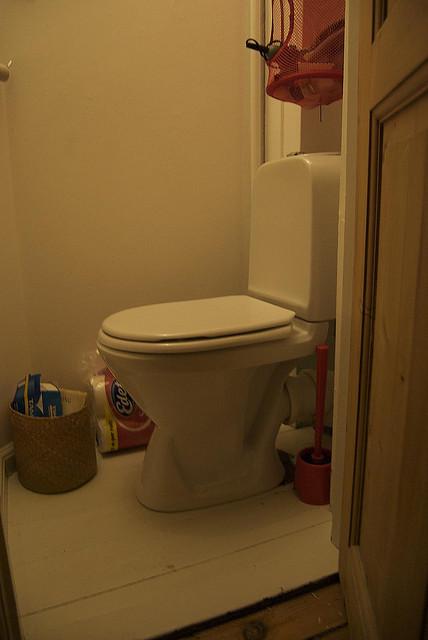Is there a mirror in this photo?
Short answer required. No. Is there a toilet cleaning item in the picture?
Quick response, please. Yes. What in this bathroom needs to be cleaned?
Short answer required. Floor. How many rugs are there?
Quick response, please. 0. What items are next to the toilet?
Write a very short answer. Toilet paper. Is toilet paper important in this area?
Give a very brief answer. Yes. Is there a shower?
Keep it brief. No. What color is the toilet?
Write a very short answer. White. Is anything in the cabinet above the toilet?
Give a very brief answer. Yes. Is this bathroom clean?
Answer briefly. Yes. 